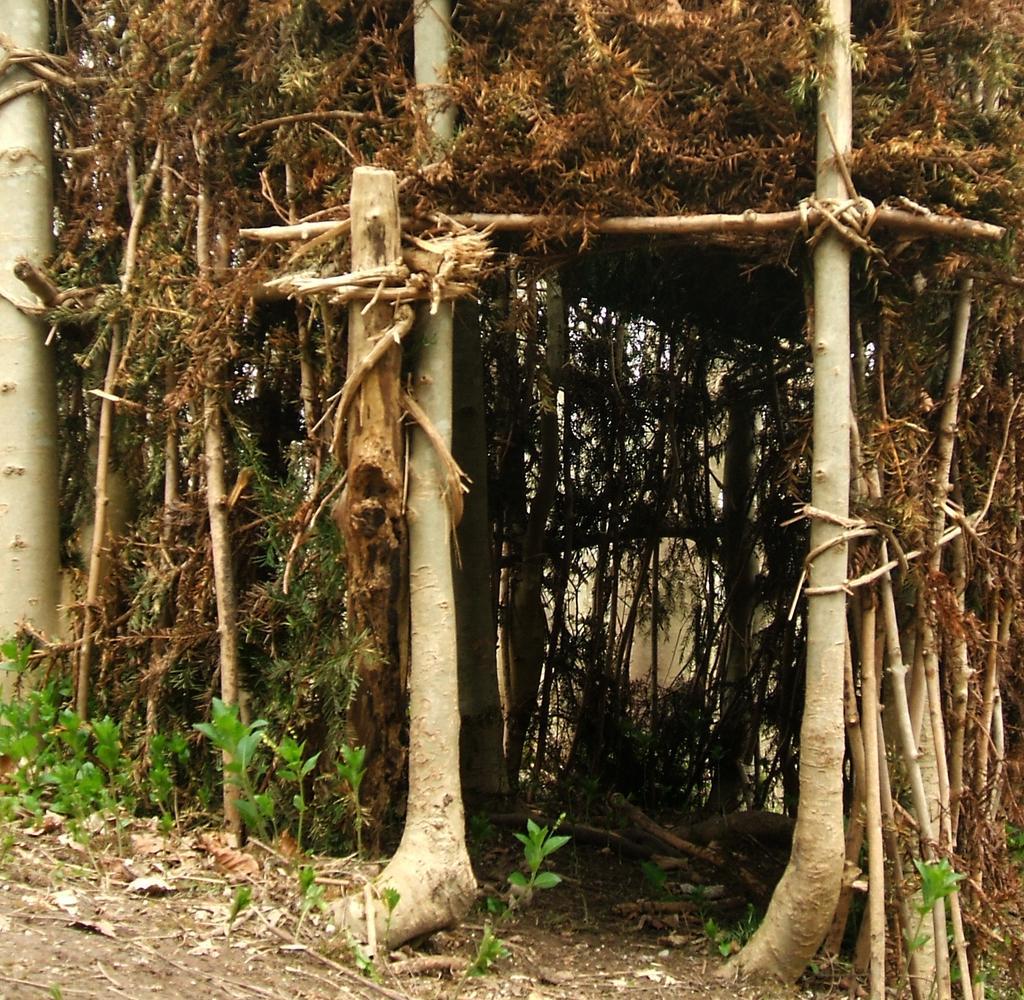Can you describe this image briefly? A picture of a hut. In-front of the but there are plants. 